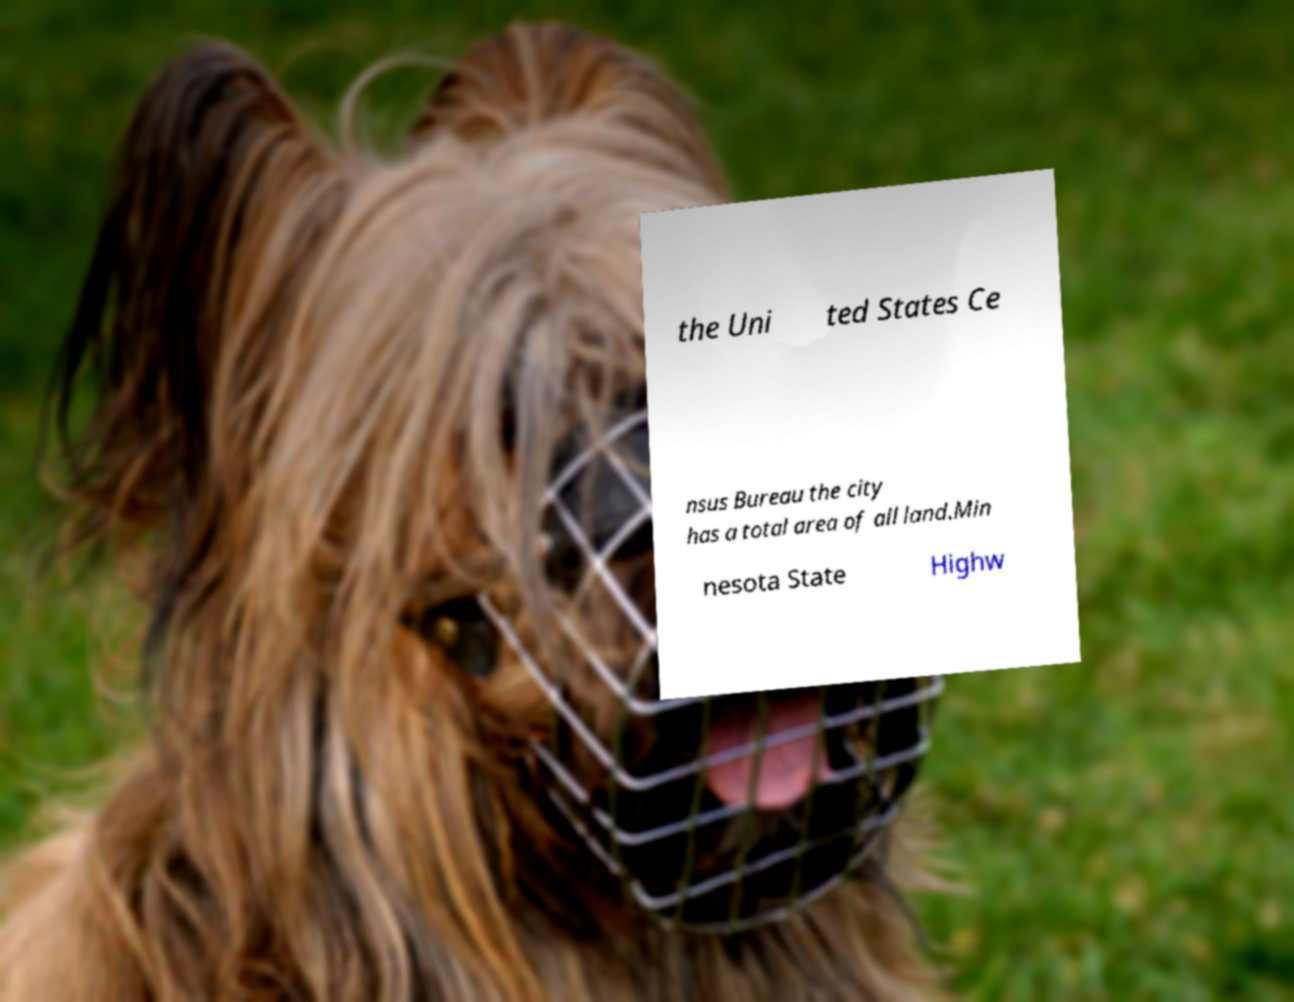Can you read and provide the text displayed in the image?This photo seems to have some interesting text. Can you extract and type it out for me? the Uni ted States Ce nsus Bureau the city has a total area of all land.Min nesota State Highw 